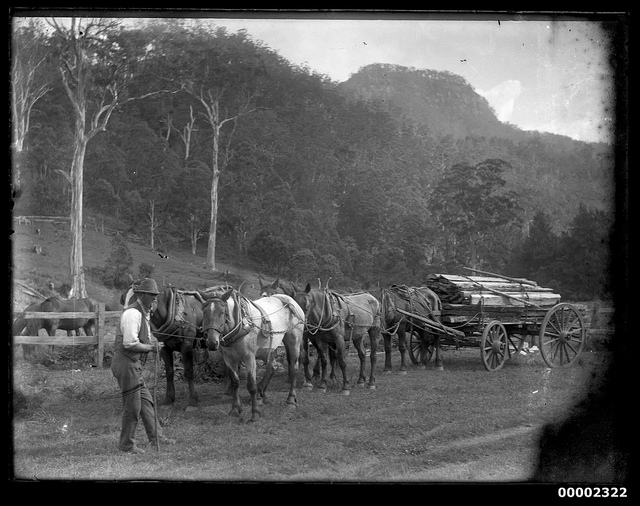Can you tell me more about the horses; how many are there? Certainly, there are six horses harnessed to the wagon in the image. They are arranged in pairs, one in front of the other, which is a typical setup for heavy draft work. This team configuration allows the horses to effectively distribute the load of the wagon and pull together synchronously. 